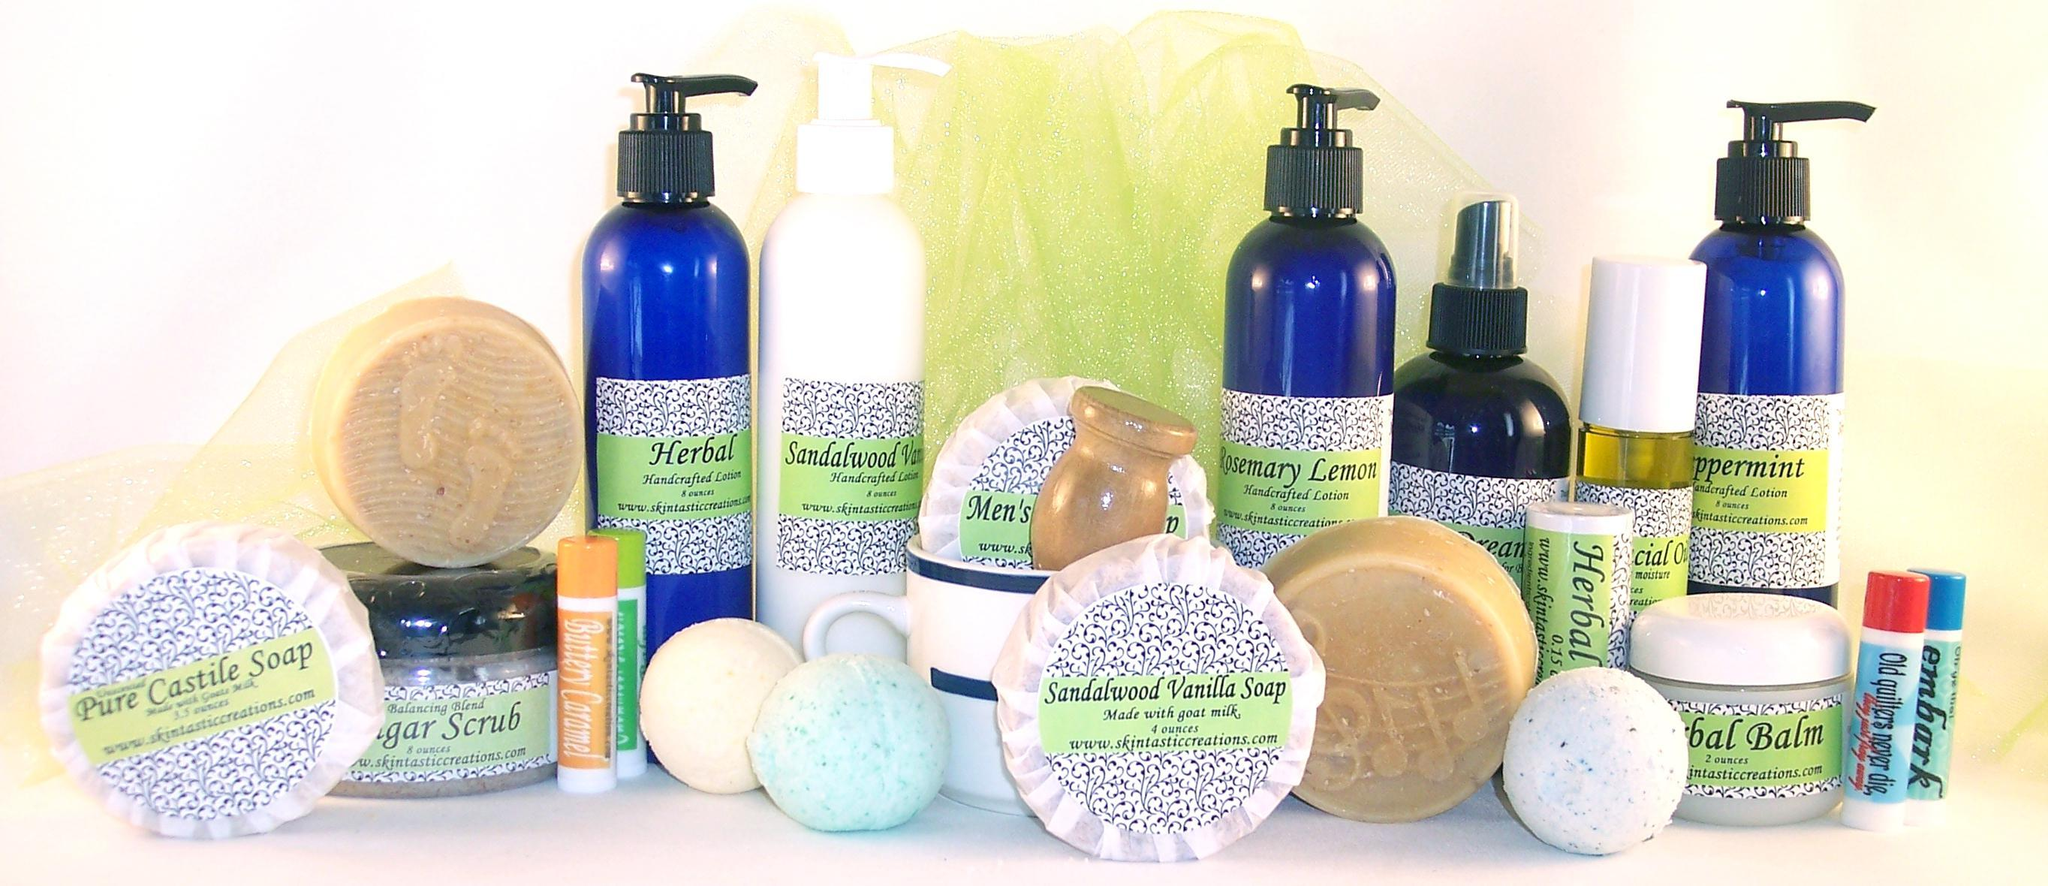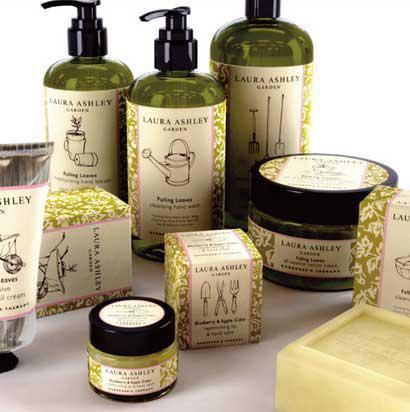The first image is the image on the left, the second image is the image on the right. Analyze the images presented: Is the assertion "One image shows a variety of skincare products displayed upright on a table, and the other image shows a variety of skincare products, all of them in a container with sides." valid? Answer yes or no. No. 